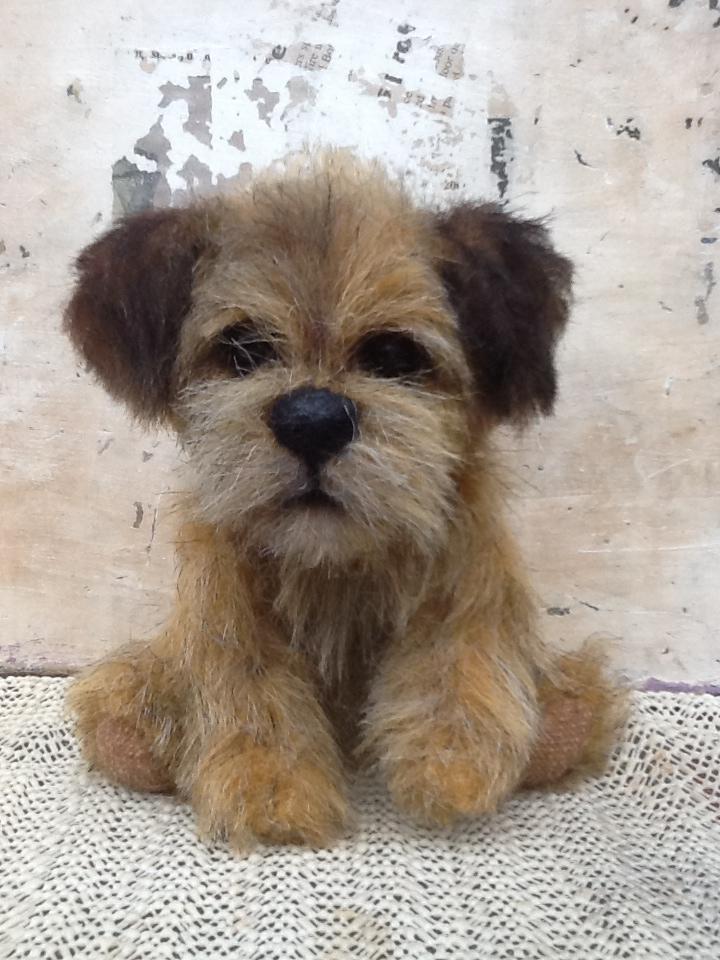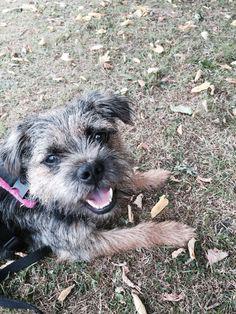The first image is the image on the left, the second image is the image on the right. Considering the images on both sides, is "The left and right image contains the same number of dogs with at least one in the grass and leaves." valid? Answer yes or no. Yes. The first image is the image on the left, the second image is the image on the right. Examine the images to the left and right. Is the description "The is an image of a black and white dog in each picture." accurate? Answer yes or no. No. 